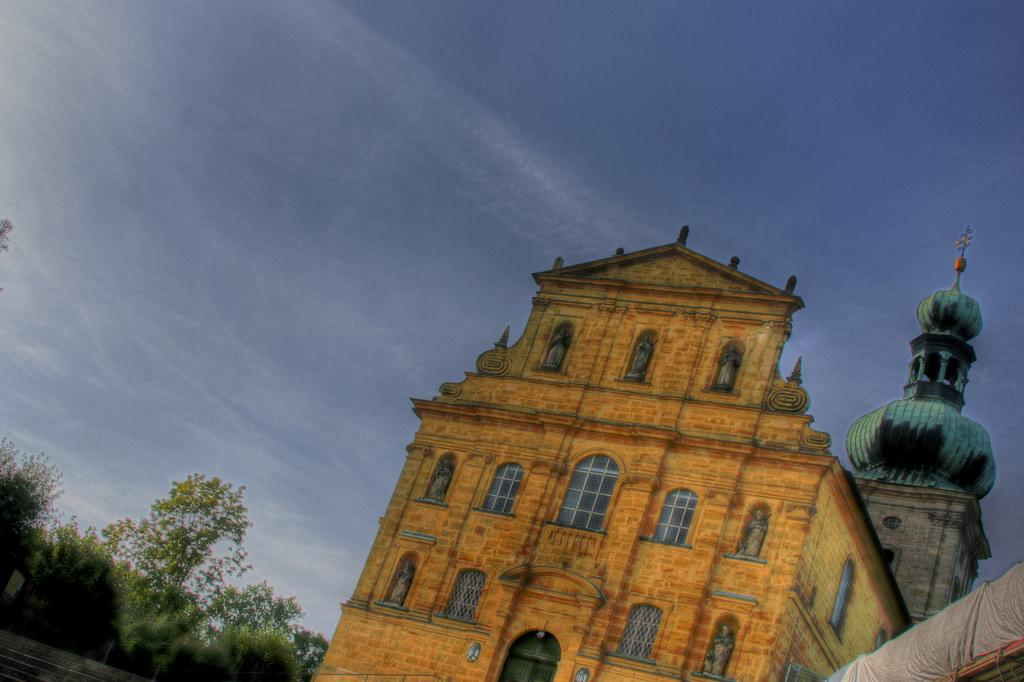What type of structure is visible in the image? There is a building in the image. What architectural feature can be seen in the image? There is an arch in the image in the image. What can be seen on the building in the image? There are windows visible on the building in the image. What type of vegetation is present in the image? There are trees and plants in the image. What is visible at the top of the image? The sky is visible at the top of the image. What type of game is being played in the image? There is no game being played in the image; it features a building, an arch, windows, trees, plants, and the sky. What type of learning material is present in the image? There is no learning material present in the image; it features a building, an arch, windows, trees, plants, and the sky. 